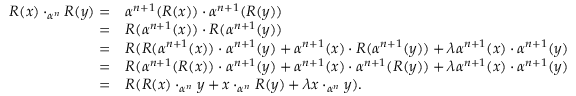Convert formula to latex. <formula><loc_0><loc_0><loc_500><loc_500>\begin{array} { r l } { R ( x ) \cdot _ { \alpha ^ { n } } R ( y ) = } & { \alpha ^ { n + 1 } ( R ( x ) ) \cdot \alpha ^ { n + 1 } ( R ( y ) ) } \\ { = } & { R ( \alpha ^ { n + 1 } ( x ) ) \cdot R ( \alpha ^ { n + 1 } ( y ) ) } \\ { = } & { R ( R ( \alpha ^ { n + 1 } ( x ) ) \cdot \alpha ^ { n + 1 } ( y ) + \alpha ^ { n + 1 } ( x ) \cdot R ( \alpha ^ { n + 1 } ( y ) ) + \lambda \alpha ^ { n + 1 } ( x ) \cdot \alpha ^ { n + 1 } ( y ) } \\ { = } & { R ( \alpha ^ { n + 1 } ( R ( x ) ) \cdot \alpha ^ { n + 1 } ( y ) + \alpha ^ { n + 1 } ( x ) \cdot \alpha ^ { n + 1 } ( R ( y ) ) + \lambda \alpha ^ { n + 1 } ( x ) \cdot \alpha ^ { n + 1 } ( y ) } \\ { = } & { R ( R ( x ) \cdot _ { \alpha ^ { n } } y + x \cdot _ { \alpha ^ { n } } R ( y ) + \lambda x \cdot _ { \alpha ^ { n } } y ) . } \end{array}</formula> 